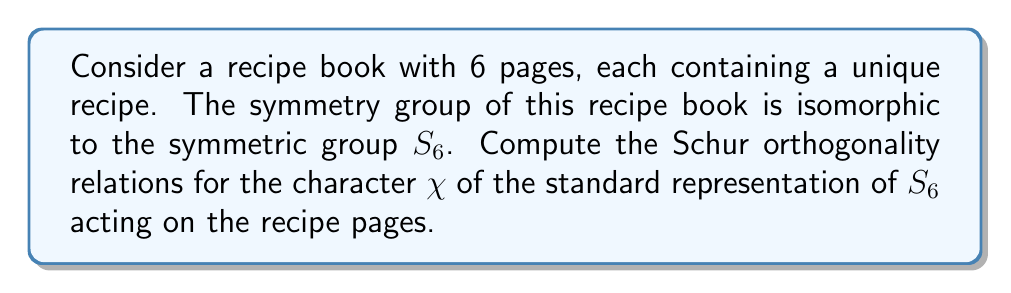Could you help me with this problem? Let's approach this step-by-step:

1) The standard representation of $S_6$ has dimension 6 (one for each recipe page).

2) The character $\chi$ of the standard representation is given by:
   $\chi(g) = \text{number of fixed points of } g - 1$

3) The Schur orthogonality relations state that for irreducible characters $\chi_i$ and $\chi_j$:

   $$\frac{1}{|G|} \sum_{g \in G} \chi_i(g) \overline{\chi_j(g)} = \delta_{ij}$$

   where $\delta_{ij}$ is the Kronecker delta.

4) In our case, we're dealing with $\chi_i = \chi_j = \chi$, so we need to compute:

   $$\frac{1}{6!} \sum_{g \in S_6} [\chi(g)]^2$$

5) To calculate this, we need to consider the cycle structure of elements in $S_6$:

   - Identity: 1 element, $\chi(e) = 5$
   - (2): 15 elements, $\chi = 3$
   - (3): 40 elements, $\chi = 2$
   - (4): 90 elements, $\chi = 1$
   - (5): 144 elements, $\chi = 0$
   - (6): 120 elements, $\chi = -1$
   - (2,2): 45 elements, $\chi = 1$
   - (2,3): 120 elements, $\chi = 0$
   - (2,2,2): 15 elements, $\chi = -1$
   - (2,4): 90 elements, $\chi = -1$
   - (3,3): 40 elements, $\chi = -1$

6) Now, let's sum $[\chi(g)]^2$ for all these elements:

   $$1 \cdot 5^2 + 15 \cdot 3^2 + 40 \cdot 2^2 + 90 \cdot 1^2 + 144 \cdot 0^2 + 120 \cdot (-1)^2 + 45 \cdot 1^2 + 120 \cdot 0^2 + 15 \cdot (-1)^2 + 90 \cdot (-1)^2 + 40 \cdot (-1)^2$$

   $$ = 25 + 135 + 160 + 90 + 0 + 120 + 45 + 0 + 15 + 90 + 40 = 720$$

7) Dividing by $|S_6| = 6! = 720$, we get:

   $$\frac{1}{6!} \sum_{g \in S_6} [\chi(g)]^2 = \frac{720}{720} = 1$$

This result confirms the Schur orthogonality relation for the standard representation of $S_6$.
Answer: 1 